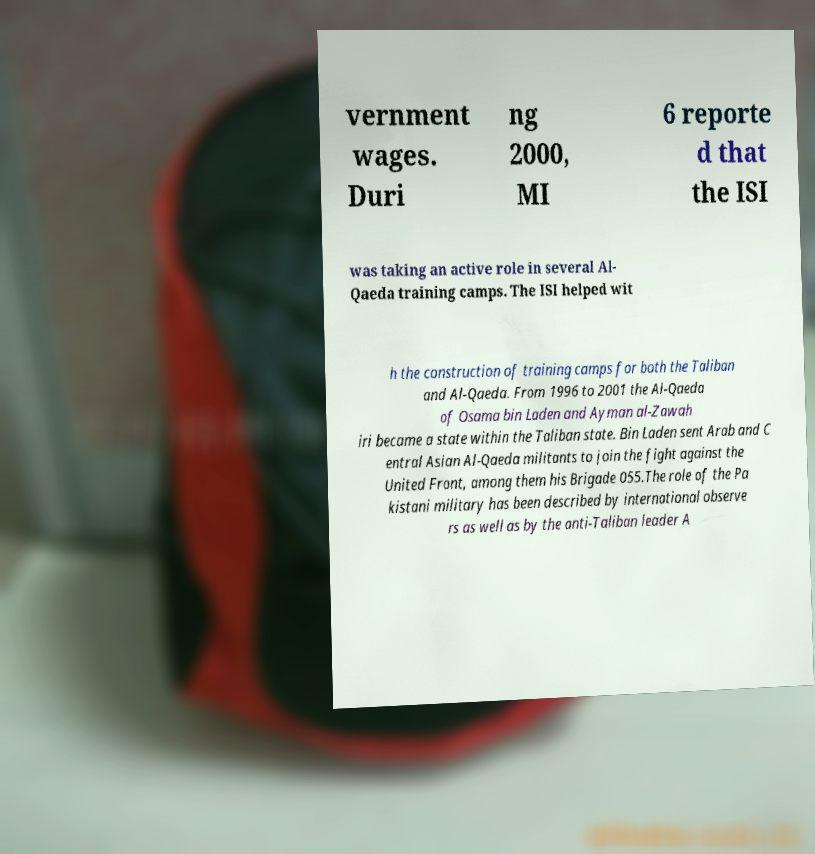Can you read and provide the text displayed in the image?This photo seems to have some interesting text. Can you extract and type it out for me? vernment wages. Duri ng 2000, MI 6 reporte d that the ISI was taking an active role in several Al- Qaeda training camps. The ISI helped wit h the construction of training camps for both the Taliban and Al-Qaeda. From 1996 to 2001 the Al-Qaeda of Osama bin Laden and Ayman al-Zawah iri became a state within the Taliban state. Bin Laden sent Arab and C entral Asian Al-Qaeda militants to join the fight against the United Front, among them his Brigade 055.The role of the Pa kistani military has been described by international observe rs as well as by the anti-Taliban leader A 